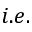Convert formula to latex. <formula><loc_0><loc_0><loc_500><loc_500>i . e .</formula> 